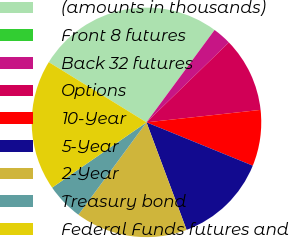<chart> <loc_0><loc_0><loc_500><loc_500><pie_chart><fcel>(amounts in thousands)<fcel>Front 8 futures<fcel>Back 32 futures<fcel>Options<fcel>10-Year<fcel>5-Year<fcel>2-Year<fcel>Treasury bond<fcel>Federal Funds futures and<nl><fcel>26.32%<fcel>0.0%<fcel>2.63%<fcel>10.53%<fcel>7.89%<fcel>13.16%<fcel>15.79%<fcel>5.26%<fcel>18.42%<nl></chart> 